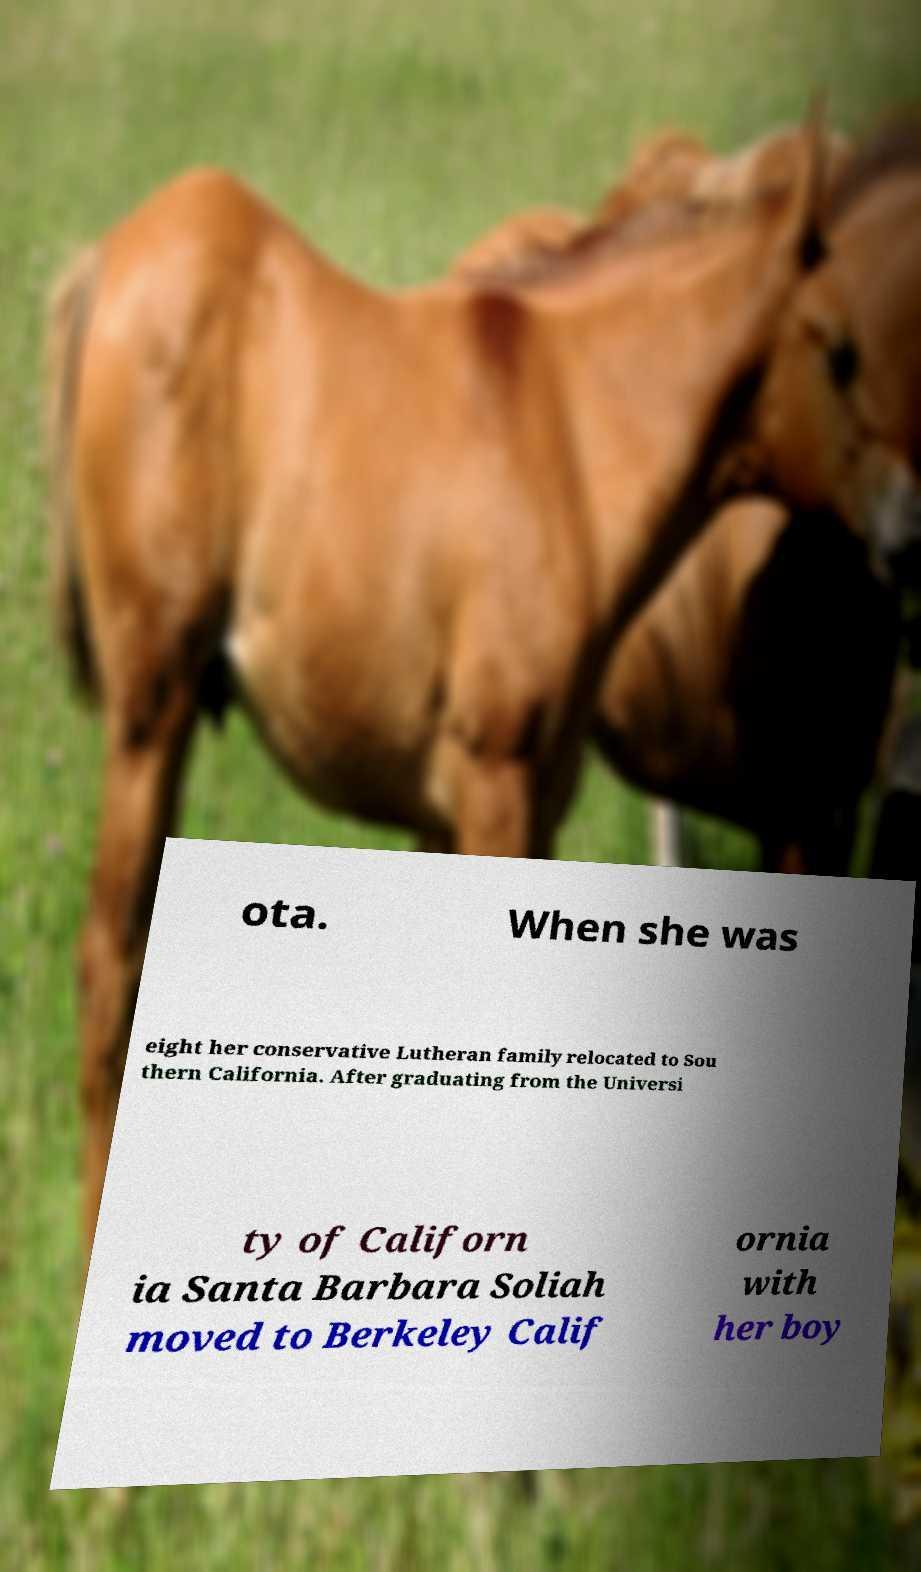I need the written content from this picture converted into text. Can you do that? ota. When she was eight her conservative Lutheran family relocated to Sou thern California. After graduating from the Universi ty of Californ ia Santa Barbara Soliah moved to Berkeley Calif ornia with her boy 